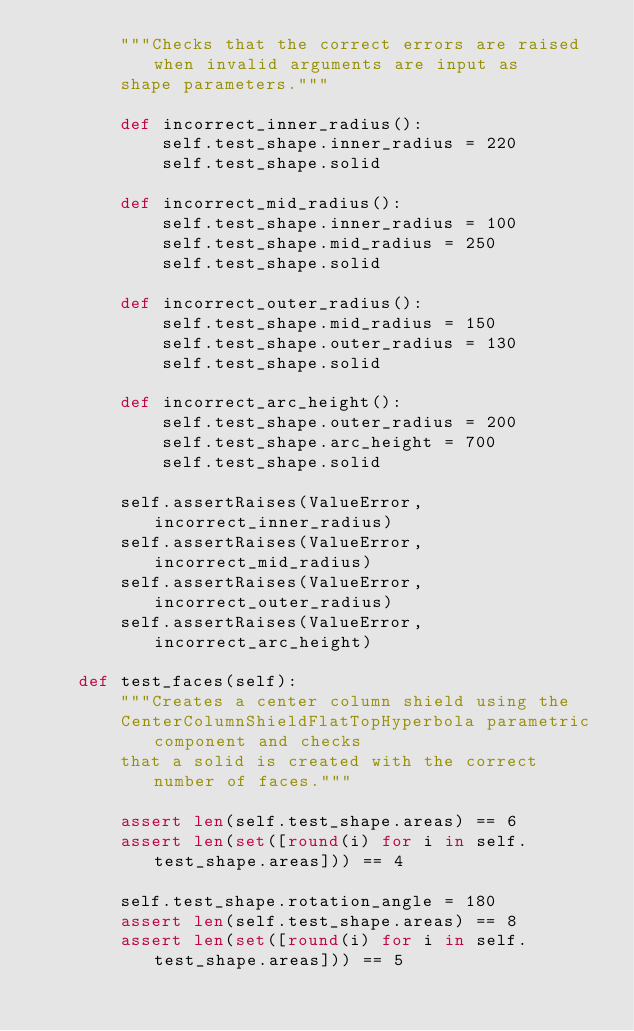<code> <loc_0><loc_0><loc_500><loc_500><_Python_>        """Checks that the correct errors are raised when invalid arguments are input as
        shape parameters."""

        def incorrect_inner_radius():
            self.test_shape.inner_radius = 220
            self.test_shape.solid

        def incorrect_mid_radius():
            self.test_shape.inner_radius = 100
            self.test_shape.mid_radius = 250
            self.test_shape.solid

        def incorrect_outer_radius():
            self.test_shape.mid_radius = 150
            self.test_shape.outer_radius = 130
            self.test_shape.solid

        def incorrect_arc_height():
            self.test_shape.outer_radius = 200
            self.test_shape.arc_height = 700
            self.test_shape.solid

        self.assertRaises(ValueError, incorrect_inner_radius)
        self.assertRaises(ValueError, incorrect_mid_radius)
        self.assertRaises(ValueError, incorrect_outer_radius)
        self.assertRaises(ValueError, incorrect_arc_height)

    def test_faces(self):
        """Creates a center column shield using the
        CenterColumnShieldFlatTopHyperbola parametric component and checks
        that a solid is created with the correct number of faces."""

        assert len(self.test_shape.areas) == 6
        assert len(set([round(i) for i in self.test_shape.areas])) == 4

        self.test_shape.rotation_angle = 180
        assert len(self.test_shape.areas) == 8
        assert len(set([round(i) for i in self.test_shape.areas])) == 5
</code> 